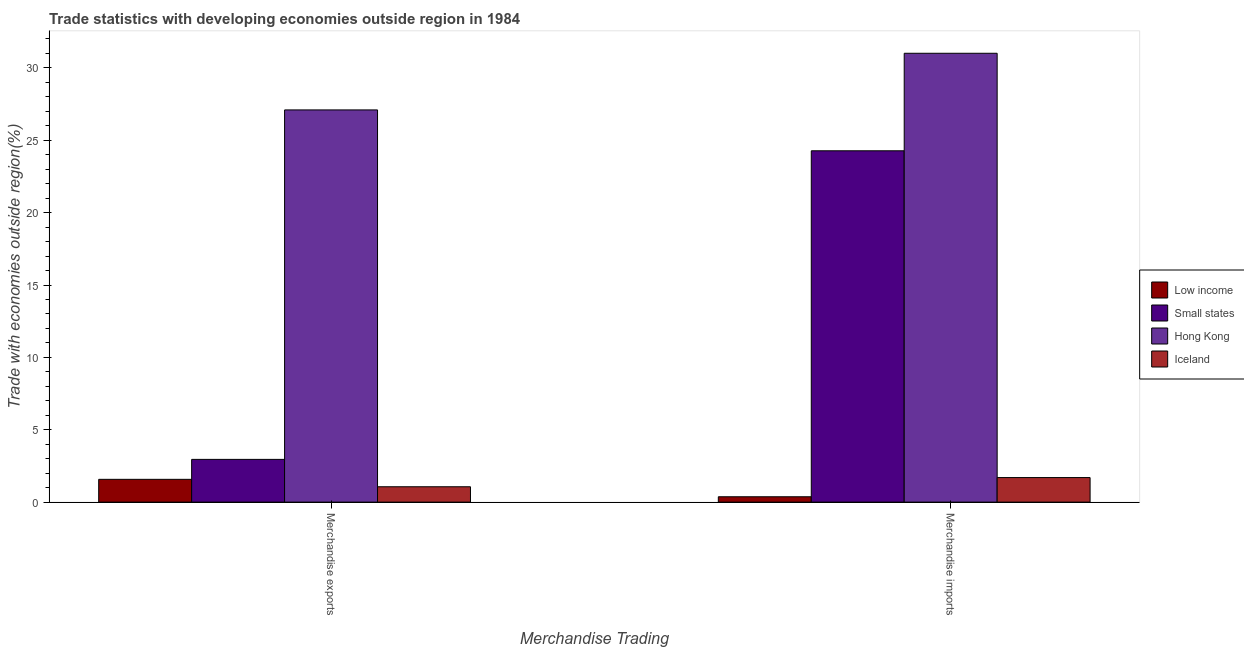How many groups of bars are there?
Provide a short and direct response. 2. Are the number of bars per tick equal to the number of legend labels?
Offer a very short reply. Yes. Are the number of bars on each tick of the X-axis equal?
Keep it short and to the point. Yes. How many bars are there on the 2nd tick from the left?
Your answer should be very brief. 4. How many bars are there on the 2nd tick from the right?
Give a very brief answer. 4. What is the label of the 1st group of bars from the left?
Give a very brief answer. Merchandise exports. What is the merchandise exports in Iceland?
Provide a short and direct response. 1.06. Across all countries, what is the maximum merchandise imports?
Ensure brevity in your answer.  31.01. Across all countries, what is the minimum merchandise imports?
Your answer should be very brief. 0.37. In which country was the merchandise imports maximum?
Provide a succinct answer. Hong Kong. What is the total merchandise exports in the graph?
Provide a succinct answer. 32.69. What is the difference between the merchandise imports in Small states and that in Low income?
Make the answer very short. 23.9. What is the difference between the merchandise exports in Hong Kong and the merchandise imports in Iceland?
Your answer should be compact. 25.4. What is the average merchandise exports per country?
Offer a very short reply. 8.17. What is the difference between the merchandise exports and merchandise imports in Iceland?
Your answer should be compact. -0.64. What is the ratio of the merchandise exports in Iceland to that in Small states?
Your answer should be compact. 0.36. In how many countries, is the merchandise exports greater than the average merchandise exports taken over all countries?
Give a very brief answer. 1. What does the 1st bar from the left in Merchandise exports represents?
Your answer should be very brief. Low income. How many bars are there?
Give a very brief answer. 8. Are all the bars in the graph horizontal?
Your answer should be compact. No. How many countries are there in the graph?
Give a very brief answer. 4. Does the graph contain grids?
Provide a succinct answer. No. How many legend labels are there?
Your answer should be very brief. 4. How are the legend labels stacked?
Ensure brevity in your answer.  Vertical. What is the title of the graph?
Keep it short and to the point. Trade statistics with developing economies outside region in 1984. What is the label or title of the X-axis?
Provide a short and direct response. Merchandise Trading. What is the label or title of the Y-axis?
Your answer should be very brief. Trade with economies outside region(%). What is the Trade with economies outside region(%) in Low income in Merchandise exports?
Make the answer very short. 1.57. What is the Trade with economies outside region(%) of Small states in Merchandise exports?
Your answer should be compact. 2.95. What is the Trade with economies outside region(%) of Hong Kong in Merchandise exports?
Your answer should be compact. 27.1. What is the Trade with economies outside region(%) in Iceland in Merchandise exports?
Provide a succinct answer. 1.06. What is the Trade with economies outside region(%) in Low income in Merchandise imports?
Your response must be concise. 0.37. What is the Trade with economies outside region(%) in Small states in Merchandise imports?
Give a very brief answer. 24.28. What is the Trade with economies outside region(%) in Hong Kong in Merchandise imports?
Make the answer very short. 31.01. What is the Trade with economies outside region(%) of Iceland in Merchandise imports?
Give a very brief answer. 1.7. Across all Merchandise Trading, what is the maximum Trade with economies outside region(%) of Low income?
Your answer should be compact. 1.57. Across all Merchandise Trading, what is the maximum Trade with economies outside region(%) of Small states?
Offer a very short reply. 24.28. Across all Merchandise Trading, what is the maximum Trade with economies outside region(%) of Hong Kong?
Offer a terse response. 31.01. Across all Merchandise Trading, what is the maximum Trade with economies outside region(%) of Iceland?
Your response must be concise. 1.7. Across all Merchandise Trading, what is the minimum Trade with economies outside region(%) in Low income?
Keep it short and to the point. 0.37. Across all Merchandise Trading, what is the minimum Trade with economies outside region(%) in Small states?
Offer a very short reply. 2.95. Across all Merchandise Trading, what is the minimum Trade with economies outside region(%) in Hong Kong?
Your response must be concise. 27.1. Across all Merchandise Trading, what is the minimum Trade with economies outside region(%) of Iceland?
Provide a succinct answer. 1.06. What is the total Trade with economies outside region(%) of Low income in the graph?
Provide a succinct answer. 1.95. What is the total Trade with economies outside region(%) of Small states in the graph?
Offer a terse response. 27.23. What is the total Trade with economies outside region(%) of Hong Kong in the graph?
Your answer should be very brief. 58.11. What is the total Trade with economies outside region(%) of Iceland in the graph?
Provide a short and direct response. 2.76. What is the difference between the Trade with economies outside region(%) of Low income in Merchandise exports and that in Merchandise imports?
Your answer should be very brief. 1.2. What is the difference between the Trade with economies outside region(%) in Small states in Merchandise exports and that in Merchandise imports?
Your answer should be very brief. -21.32. What is the difference between the Trade with economies outside region(%) in Hong Kong in Merchandise exports and that in Merchandise imports?
Make the answer very short. -3.91. What is the difference between the Trade with economies outside region(%) in Iceland in Merchandise exports and that in Merchandise imports?
Give a very brief answer. -0.64. What is the difference between the Trade with economies outside region(%) of Low income in Merchandise exports and the Trade with economies outside region(%) of Small states in Merchandise imports?
Keep it short and to the point. -22.7. What is the difference between the Trade with economies outside region(%) of Low income in Merchandise exports and the Trade with economies outside region(%) of Hong Kong in Merchandise imports?
Provide a short and direct response. -29.44. What is the difference between the Trade with economies outside region(%) in Low income in Merchandise exports and the Trade with economies outside region(%) in Iceland in Merchandise imports?
Offer a very short reply. -0.12. What is the difference between the Trade with economies outside region(%) in Small states in Merchandise exports and the Trade with economies outside region(%) in Hong Kong in Merchandise imports?
Make the answer very short. -28.06. What is the difference between the Trade with economies outside region(%) of Small states in Merchandise exports and the Trade with economies outside region(%) of Iceland in Merchandise imports?
Your answer should be compact. 1.26. What is the difference between the Trade with economies outside region(%) of Hong Kong in Merchandise exports and the Trade with economies outside region(%) of Iceland in Merchandise imports?
Your answer should be very brief. 25.4. What is the average Trade with economies outside region(%) in Low income per Merchandise Trading?
Offer a terse response. 0.97. What is the average Trade with economies outside region(%) of Small states per Merchandise Trading?
Provide a succinct answer. 13.61. What is the average Trade with economies outside region(%) in Hong Kong per Merchandise Trading?
Make the answer very short. 29.06. What is the average Trade with economies outside region(%) of Iceland per Merchandise Trading?
Offer a terse response. 1.38. What is the difference between the Trade with economies outside region(%) of Low income and Trade with economies outside region(%) of Small states in Merchandise exports?
Provide a succinct answer. -1.38. What is the difference between the Trade with economies outside region(%) in Low income and Trade with economies outside region(%) in Hong Kong in Merchandise exports?
Keep it short and to the point. -25.53. What is the difference between the Trade with economies outside region(%) of Low income and Trade with economies outside region(%) of Iceland in Merchandise exports?
Provide a short and direct response. 0.51. What is the difference between the Trade with economies outside region(%) of Small states and Trade with economies outside region(%) of Hong Kong in Merchandise exports?
Your answer should be very brief. -24.15. What is the difference between the Trade with economies outside region(%) of Small states and Trade with economies outside region(%) of Iceland in Merchandise exports?
Make the answer very short. 1.89. What is the difference between the Trade with economies outside region(%) of Hong Kong and Trade with economies outside region(%) of Iceland in Merchandise exports?
Make the answer very short. 26.04. What is the difference between the Trade with economies outside region(%) of Low income and Trade with economies outside region(%) of Small states in Merchandise imports?
Your response must be concise. -23.9. What is the difference between the Trade with economies outside region(%) in Low income and Trade with economies outside region(%) in Hong Kong in Merchandise imports?
Offer a very short reply. -30.64. What is the difference between the Trade with economies outside region(%) of Low income and Trade with economies outside region(%) of Iceland in Merchandise imports?
Your answer should be very brief. -1.33. What is the difference between the Trade with economies outside region(%) of Small states and Trade with economies outside region(%) of Hong Kong in Merchandise imports?
Offer a very short reply. -6.74. What is the difference between the Trade with economies outside region(%) of Small states and Trade with economies outside region(%) of Iceland in Merchandise imports?
Offer a terse response. 22.58. What is the difference between the Trade with economies outside region(%) in Hong Kong and Trade with economies outside region(%) in Iceland in Merchandise imports?
Provide a succinct answer. 29.32. What is the ratio of the Trade with economies outside region(%) in Low income in Merchandise exports to that in Merchandise imports?
Give a very brief answer. 4.25. What is the ratio of the Trade with economies outside region(%) of Small states in Merchandise exports to that in Merchandise imports?
Provide a succinct answer. 0.12. What is the ratio of the Trade with economies outside region(%) of Hong Kong in Merchandise exports to that in Merchandise imports?
Ensure brevity in your answer.  0.87. What is the ratio of the Trade with economies outside region(%) of Iceland in Merchandise exports to that in Merchandise imports?
Provide a short and direct response. 0.63. What is the difference between the highest and the second highest Trade with economies outside region(%) of Low income?
Ensure brevity in your answer.  1.2. What is the difference between the highest and the second highest Trade with economies outside region(%) in Small states?
Offer a terse response. 21.32. What is the difference between the highest and the second highest Trade with economies outside region(%) of Hong Kong?
Your answer should be very brief. 3.91. What is the difference between the highest and the second highest Trade with economies outside region(%) in Iceland?
Offer a very short reply. 0.64. What is the difference between the highest and the lowest Trade with economies outside region(%) in Low income?
Ensure brevity in your answer.  1.2. What is the difference between the highest and the lowest Trade with economies outside region(%) of Small states?
Offer a very short reply. 21.32. What is the difference between the highest and the lowest Trade with economies outside region(%) in Hong Kong?
Provide a short and direct response. 3.91. What is the difference between the highest and the lowest Trade with economies outside region(%) in Iceland?
Your response must be concise. 0.64. 